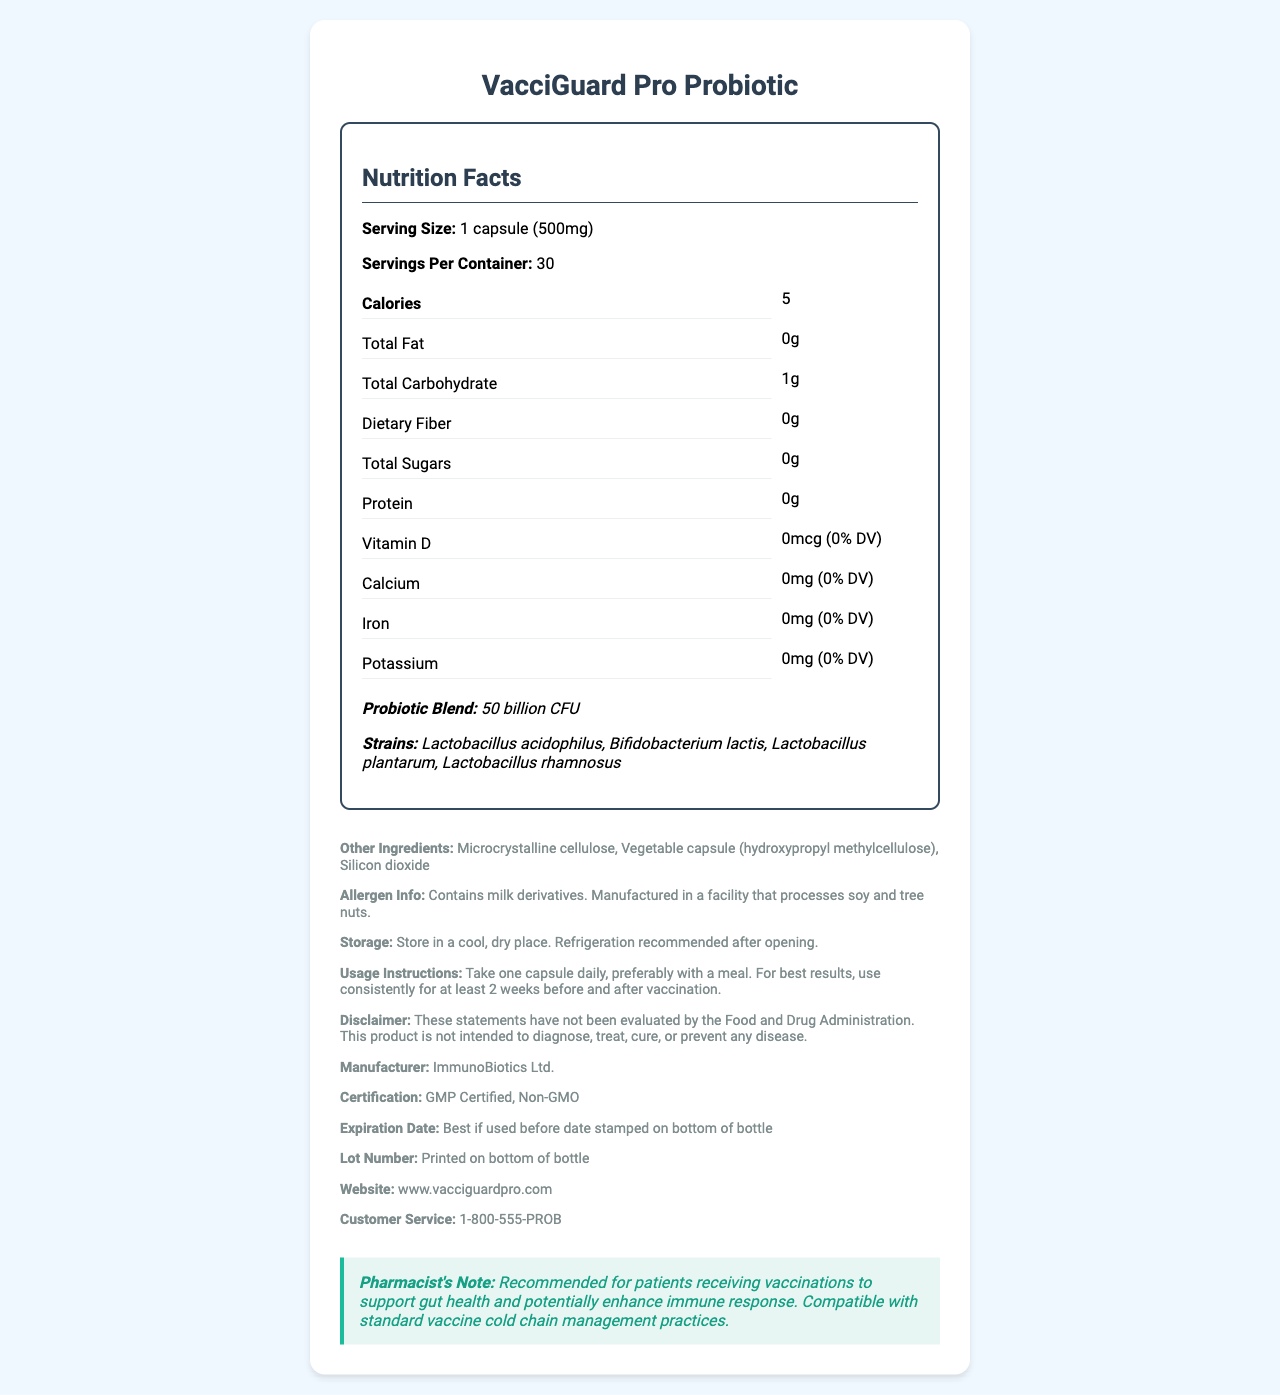what is the serving size of VacciGuard Pro Probiotic? The serving size is explicitly mentioned as "1 capsule (500mg)" in the nutrition facts section.
Answer: 1 capsule (500mg) how many calories are in one serving? The document states that one serving contains 5 calories.
Answer: 5 which probiotic strains are included in the VacciGuard Pro Probiotic? The probiotic strains listed are Lactobacillus acidophilus, Bifidobacterium lactis, Lactobacillus plantarum, and Lactobacillus rhamnosus.
Answer: Lactobacillus acidophilus, Bifidobacterium lactis, Lactobacillus plantarum, Lactobacillus rhamnosus what is the recommended storage condition after opening the bottle? The storage instructions mention that refrigeration is recommended after opening.
Answer: Refrigeration recommended how many servings are there per container? The document specifies that there are 30 servings per container.
Answer: 30 which of the following ingredients are found in the VacciGuard Pro Probiotic? A. Lactobacillus acidophilus B. Vitamin C C. Silicon dioxide D. Calcium Lactobacillus acidophilus and Silicon dioxide are listed ingredients, while Vitamin C and Calcium are not included.
Answer: A, C what is the total carbohydrate content per serving? A. 0g B. 1g C. 5g D. 10g The nutrition facts indicate that the total carbohydrate content per serving is 1g.
Answer: B do the nutrition facts indicate the presence of any protein in the supplement? The document shows that the protein content is 0g per serving.
Answer: No is this product gluten-free? The provided information does not specify whether the product is gluten-free.
Answer: Cannot be determined can this product diagnose, treat, cure, or prevent any disease? The disclaimer clearly states that the product is not intended to diagnose, treat, cure, or prevent any disease.
Answer: No summarize the main purpose and key information of this document. The document mainly describes the nutritional facts and details about the VacciGuard Pro Probiotic supplement, including its probiotic blend, serving size, storage instructions, and suitability for those receiving vaccinations. It also provides important allergen and regulatory information.
Answer: The primary purpose of this document is to provide a detailed overview of the nutritional content and ingredient list of VacciGuard Pro Probiotic, a supplement designed to promote gut health. It provides information on serving size, calories, and specific probiotic strains included. The document also includes usage instructions, storage recommendations, allergen information, and a note from the pharmacist. The product is recommended for individuals receiving vaccinations, and it adheres to certain certifications. 